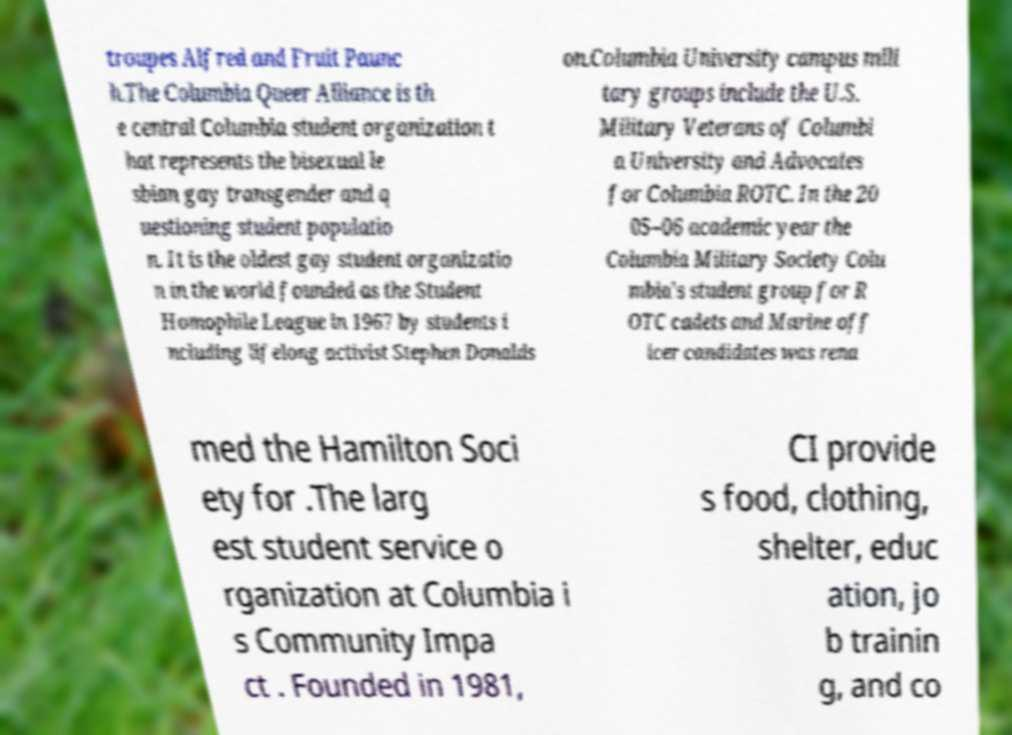Could you extract and type out the text from this image? troupes Alfred and Fruit Paunc h.The Columbia Queer Alliance is th e central Columbia student organization t hat represents the bisexual le sbian gay transgender and q uestioning student populatio n. It is the oldest gay student organizatio n in the world founded as the Student Homophile League in 1967 by students i ncluding lifelong activist Stephen Donalds on.Columbia University campus mili tary groups include the U.S. Military Veterans of Columbi a University and Advocates for Columbia ROTC. In the 20 05–06 academic year the Columbia Military Society Colu mbia's student group for R OTC cadets and Marine off icer candidates was rena med the Hamilton Soci ety for .The larg est student service o rganization at Columbia i s Community Impa ct . Founded in 1981, CI provide s food, clothing, shelter, educ ation, jo b trainin g, and co 